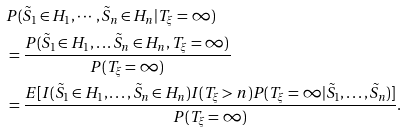Convert formula to latex. <formula><loc_0><loc_0><loc_500><loc_500>& P ( \tilde { S } _ { 1 } \in H _ { 1 } , \cdots , \tilde { S } _ { n } \in H _ { n } | T _ { \xi } = \infty ) \\ & = \frac { P ( \tilde { S } _ { 1 } \in H _ { 1 } , \dots \tilde { S } _ { n } \in H _ { n } , T _ { \xi } = \infty ) } { P ( T _ { \xi } = \infty ) } \\ & = \frac { E [ I ( \tilde { S } _ { 1 } \in H _ { 1 } , \dots , \tilde { S } _ { n } \in H _ { n } ) I ( T _ { \xi } > n ) P ( T _ { \xi } = \infty | \tilde { S } _ { 1 } , \dots , \tilde { S } _ { n } ) ] } { P ( T _ { \xi } = \infty ) } .</formula> 